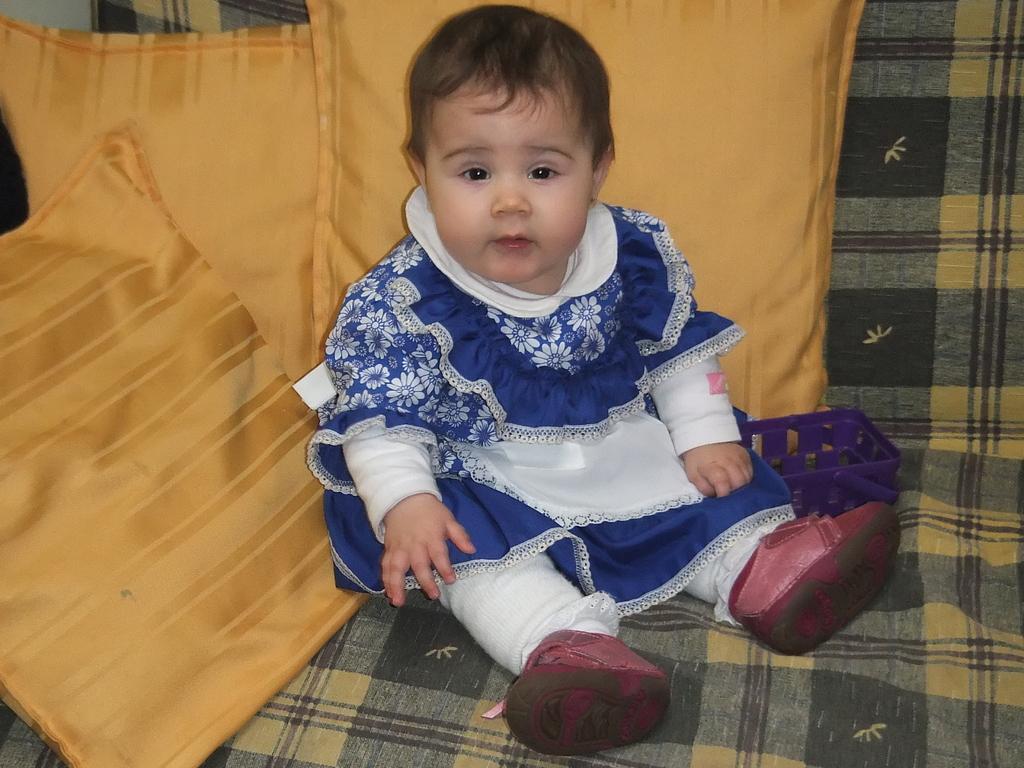Describe this image in one or two sentences. In this picture there is a kid with white and blue dress is sitting on the sofa and there are three yellow color pillows on the sofa. 